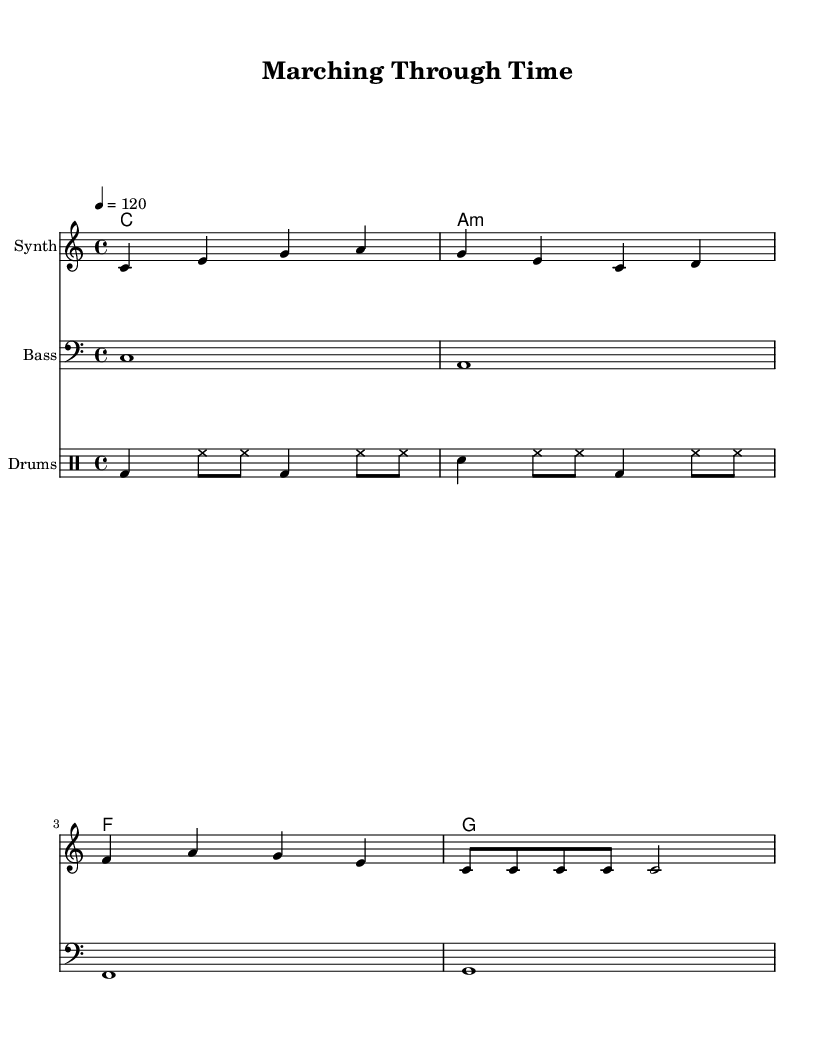What is the key signature of this music? The key signature is C major, which has no sharps or flats.
Answer: C major What is the time signature of the piece? The time signature is indicated at the beginning of the score and is shown as a 4 over 4, meaning there are four beats in each measure.
Answer: 4/4 What is the tempo marking for this composition? The tempo marking is written as “4 = 120”, which indicates that there are 120 beats per minute in quarter notes.
Answer: 120 How many measures are in the melody? By counting the musical measures in the melody section, we find there are six measures in total.
Answer: 6 What chord follows the C major chord in the harmonies section? The second chord in the harmonies is labeled as A minor (a:m), which directly follows the C major chord.
Answer: A minor Which instrument is featured as the bass? The bass is indicated to be played in the staff labeled "Bass," which represents the bass section of the music.
Answer: Bass How many distinct drum patterns are included in the drum section? The drum patterns listed consist of two distinct measures, each showcasing variations with bass drums (bd), hi-hats (hh), and snare (sn).
Answer: 2 